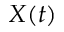<formula> <loc_0><loc_0><loc_500><loc_500>X ( t )</formula> 